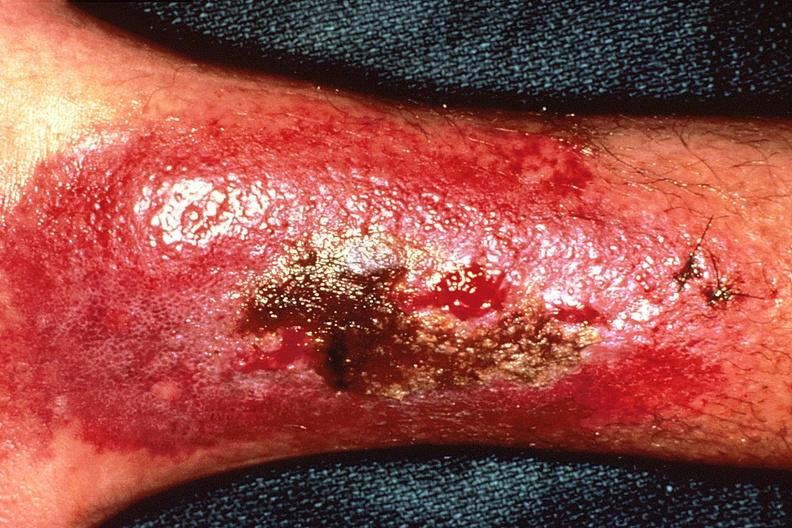where is this?
Answer the question using a single word or phrase. Skin 